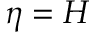Convert formula to latex. <formula><loc_0><loc_0><loc_500><loc_500>\eta = H</formula> 